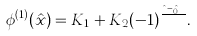Convert formula to latex. <formula><loc_0><loc_0><loc_500><loc_500>\phi ^ { ( 1 ) } ( \hat { x } ) = K _ { 1 } + K _ { 2 } ( - 1 ) ^ { \frac { { \hat { x } } - \hat { x } _ { 0 } } { h } } .</formula> 